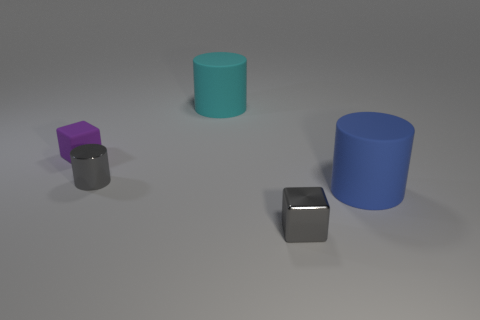Add 4 small gray blocks. How many objects exist? 9 Subtract all cylinders. How many objects are left? 2 Add 4 brown balls. How many brown balls exist? 4 Subtract 0 red spheres. How many objects are left? 5 Subtract all small gray metal blocks. Subtract all big brown cylinders. How many objects are left? 4 Add 3 purple matte objects. How many purple matte objects are left? 4 